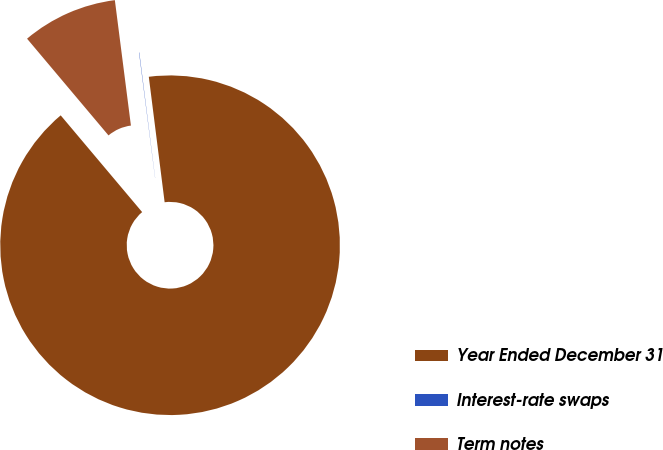Convert chart to OTSL. <chart><loc_0><loc_0><loc_500><loc_500><pie_chart><fcel>Year Ended December 31<fcel>Interest-rate swaps<fcel>Term notes<nl><fcel>90.85%<fcel>0.03%<fcel>9.11%<nl></chart> 